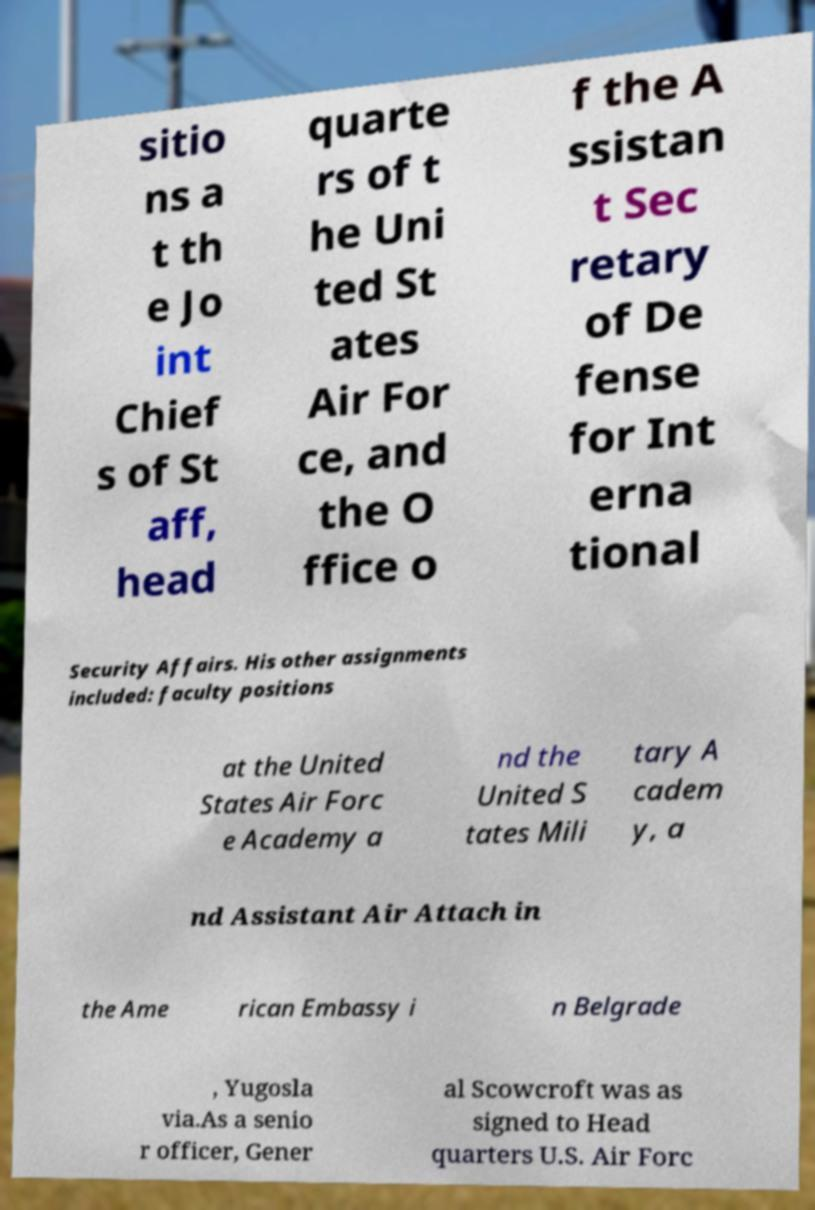Could you extract and type out the text from this image? sitio ns a t th e Jo int Chief s of St aff, head quarte rs of t he Uni ted St ates Air For ce, and the O ffice o f the A ssistan t Sec retary of De fense for Int erna tional Security Affairs. His other assignments included: faculty positions at the United States Air Forc e Academy a nd the United S tates Mili tary A cadem y, a nd Assistant Air Attach in the Ame rican Embassy i n Belgrade , Yugosla via.As a senio r officer, Gener al Scowcroft was as signed to Head quarters U.S. Air Forc 